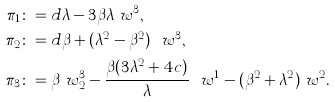Convert formula to latex. <formula><loc_0><loc_0><loc_500><loc_500>\pi _ { 1 } & \colon = d \lambda - 3 \beta \lambda \ w ^ { 3 } , \\ \pi _ { 2 } & \colon = d \beta + ( \lambda ^ { 2 } - \beta ^ { 2 } ) \ \ w ^ { 3 } , \\ \pi _ { 3 } & \colon = \beta \ w ^ { 3 } _ { 2 } - \frac { \beta ( 3 \lambda ^ { 2 } + 4 c ) } { \lambda } \ \ w ^ { 1 } - ( \beta ^ { 2 } + \lambda ^ { 2 } ) \ w ^ { 2 } .</formula> 